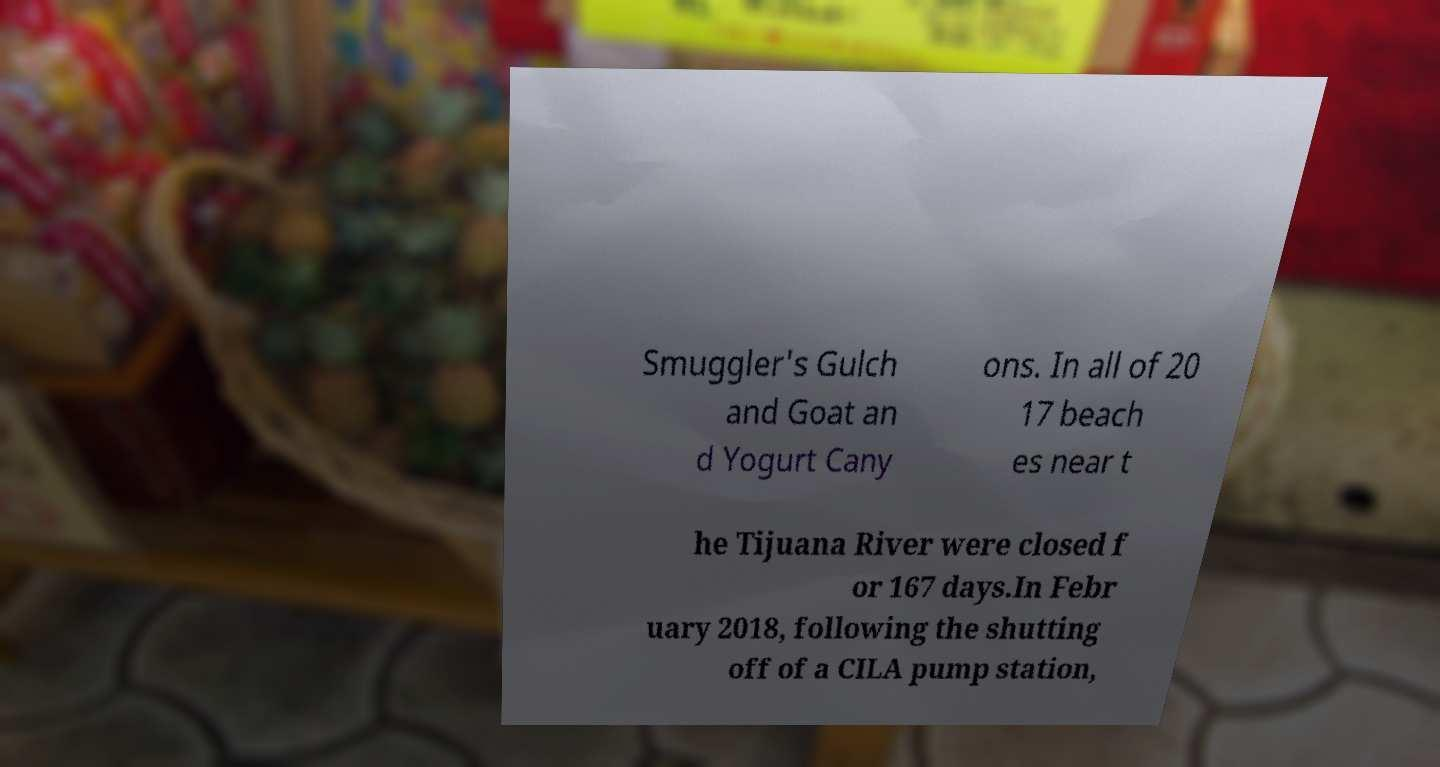Could you assist in decoding the text presented in this image and type it out clearly? Smuggler's Gulch and Goat an d Yogurt Cany ons. In all of 20 17 beach es near t he Tijuana River were closed f or 167 days.In Febr uary 2018, following the shutting off of a CILA pump station, 